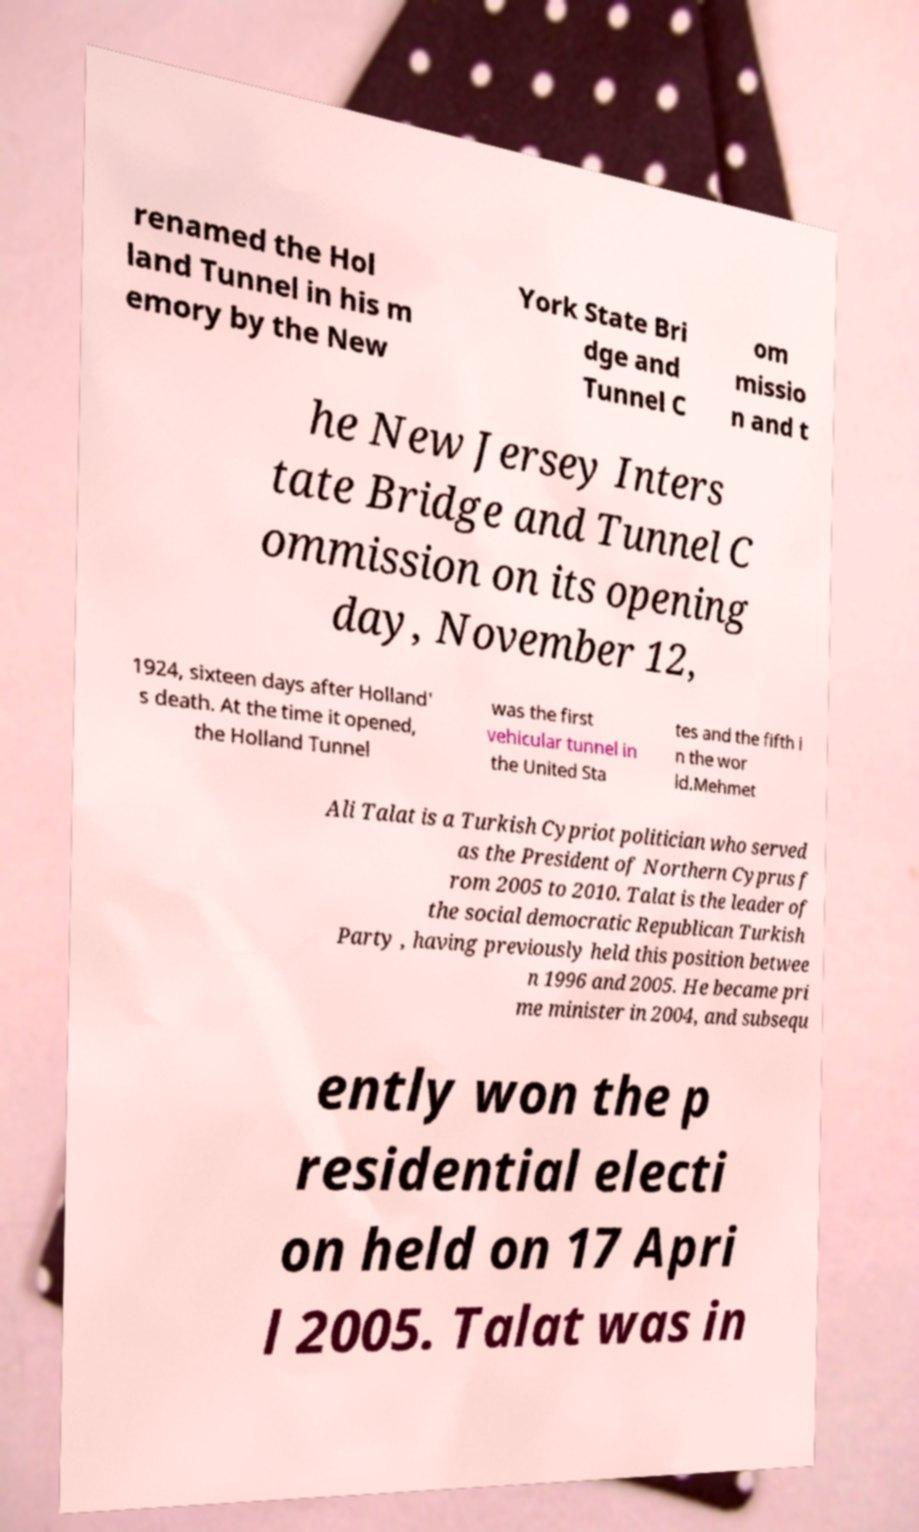For documentation purposes, I need the text within this image transcribed. Could you provide that? renamed the Hol land Tunnel in his m emory by the New York State Bri dge and Tunnel C om missio n and t he New Jersey Inters tate Bridge and Tunnel C ommission on its opening day, November 12, 1924, sixteen days after Holland' s death. At the time it opened, the Holland Tunnel was the first vehicular tunnel in the United Sta tes and the fifth i n the wor ld.Mehmet Ali Talat is a Turkish Cypriot politician who served as the President of Northern Cyprus f rom 2005 to 2010. Talat is the leader of the social democratic Republican Turkish Party , having previously held this position betwee n 1996 and 2005. He became pri me minister in 2004, and subsequ ently won the p residential electi on held on 17 Apri l 2005. Talat was in 